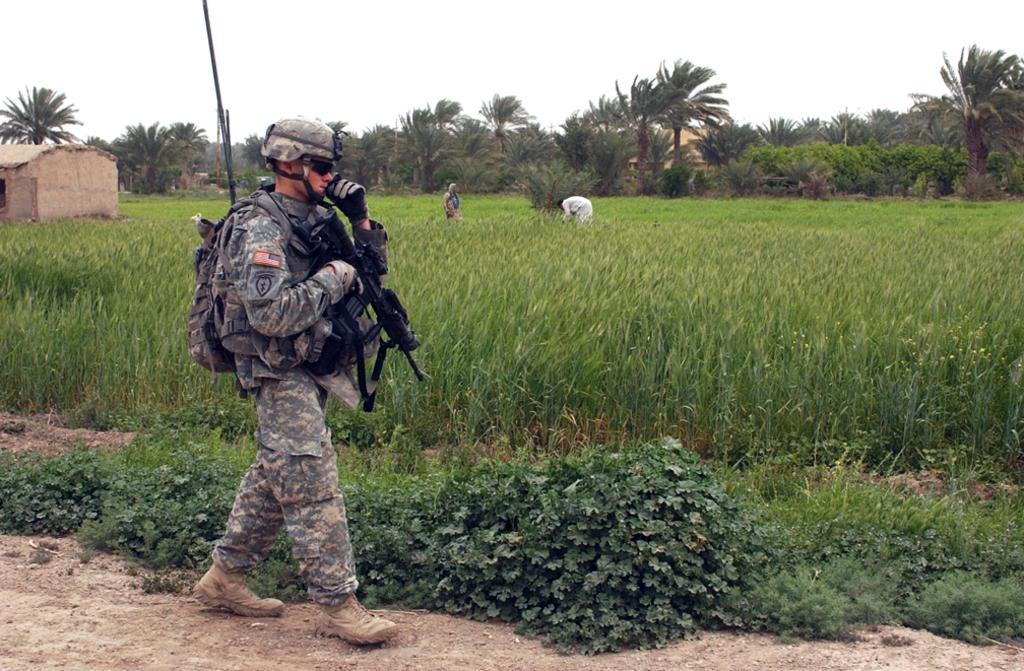Could you give a brief overview of what you see in this image? In the foreground of the picture there is a soldier walking on a mud road holding backpack and wearing helmet and spectacles and gun and there are plants. In the center of the picture there is a field and there are people and houses. In the background there are trees and houses. Sky is cloudy. 